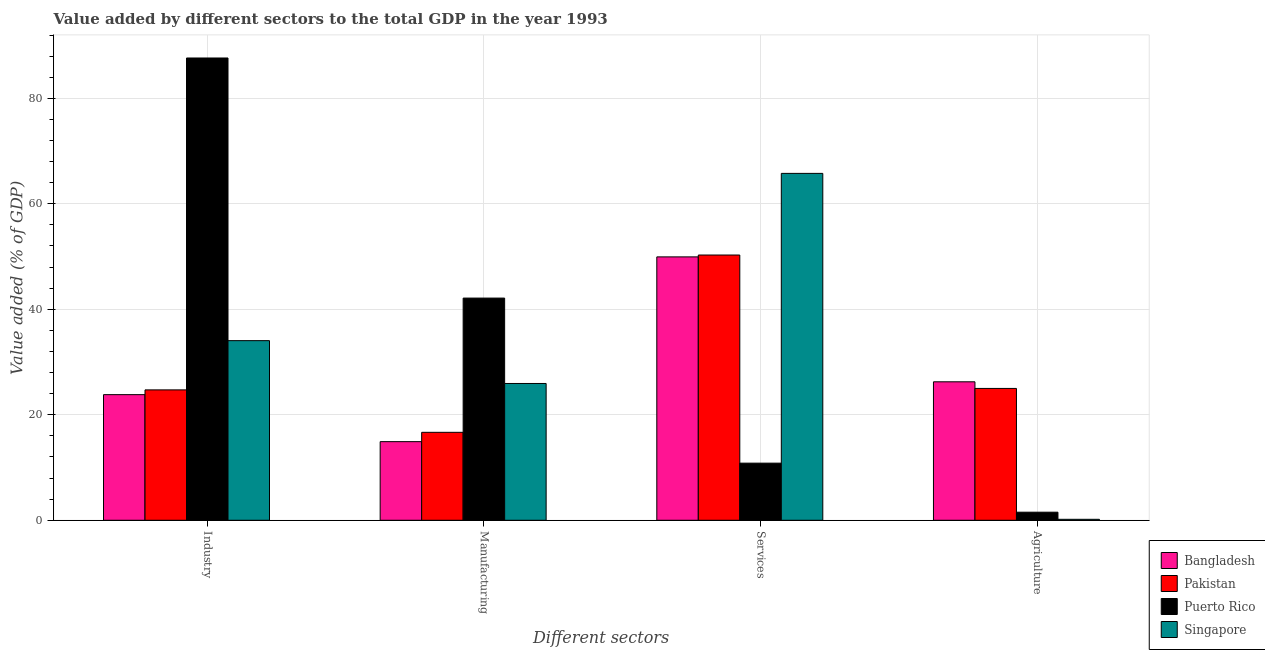Are the number of bars on each tick of the X-axis equal?
Provide a succinct answer. Yes. How many bars are there on the 4th tick from the right?
Give a very brief answer. 4. What is the label of the 3rd group of bars from the left?
Your answer should be very brief. Services. What is the value added by manufacturing sector in Bangladesh?
Give a very brief answer. 14.91. Across all countries, what is the maximum value added by manufacturing sector?
Give a very brief answer. 42.12. Across all countries, what is the minimum value added by services sector?
Your response must be concise. 10.83. In which country was the value added by services sector maximum?
Offer a terse response. Singapore. In which country was the value added by services sector minimum?
Provide a short and direct response. Puerto Rico. What is the total value added by agricultural sector in the graph?
Make the answer very short. 52.96. What is the difference between the value added by services sector in Puerto Rico and that in Singapore?
Give a very brief answer. -54.94. What is the difference between the value added by manufacturing sector in Pakistan and the value added by industrial sector in Puerto Rico?
Your answer should be compact. -70.97. What is the average value added by manufacturing sector per country?
Provide a succinct answer. 24.91. What is the difference between the value added by manufacturing sector and value added by services sector in Singapore?
Your response must be concise. -39.83. What is the ratio of the value added by services sector in Bangladesh to that in Puerto Rico?
Provide a short and direct response. 4.61. Is the value added by agricultural sector in Singapore less than that in Puerto Rico?
Your answer should be compact. Yes. What is the difference between the highest and the second highest value added by manufacturing sector?
Make the answer very short. 16.19. What is the difference between the highest and the lowest value added by industrial sector?
Offer a terse response. 63.83. Is it the case that in every country, the sum of the value added by services sector and value added by agricultural sector is greater than the sum of value added by manufacturing sector and value added by industrial sector?
Offer a terse response. No. Is it the case that in every country, the sum of the value added by industrial sector and value added by manufacturing sector is greater than the value added by services sector?
Provide a succinct answer. No. How many countries are there in the graph?
Offer a very short reply. 4. Where does the legend appear in the graph?
Make the answer very short. Bottom right. How many legend labels are there?
Make the answer very short. 4. What is the title of the graph?
Ensure brevity in your answer.  Value added by different sectors to the total GDP in the year 1993. What is the label or title of the X-axis?
Provide a short and direct response. Different sectors. What is the label or title of the Y-axis?
Ensure brevity in your answer.  Value added (% of GDP). What is the Value added (% of GDP) of Bangladesh in Industry?
Your response must be concise. 23.82. What is the Value added (% of GDP) in Pakistan in Industry?
Keep it short and to the point. 24.72. What is the Value added (% of GDP) of Puerto Rico in Industry?
Offer a terse response. 87.64. What is the Value added (% of GDP) in Singapore in Industry?
Provide a succinct answer. 34.05. What is the Value added (% of GDP) of Bangladesh in Manufacturing?
Keep it short and to the point. 14.91. What is the Value added (% of GDP) in Pakistan in Manufacturing?
Ensure brevity in your answer.  16.67. What is the Value added (% of GDP) of Puerto Rico in Manufacturing?
Ensure brevity in your answer.  42.12. What is the Value added (% of GDP) in Singapore in Manufacturing?
Offer a terse response. 25.93. What is the Value added (% of GDP) in Bangladesh in Services?
Make the answer very short. 49.93. What is the Value added (% of GDP) of Pakistan in Services?
Provide a succinct answer. 50.29. What is the Value added (% of GDP) in Puerto Rico in Services?
Provide a succinct answer. 10.83. What is the Value added (% of GDP) of Singapore in Services?
Provide a short and direct response. 65.76. What is the Value added (% of GDP) in Bangladesh in Agriculture?
Provide a short and direct response. 26.25. What is the Value added (% of GDP) in Pakistan in Agriculture?
Your response must be concise. 24.99. What is the Value added (% of GDP) of Puerto Rico in Agriculture?
Your answer should be very brief. 1.53. What is the Value added (% of GDP) of Singapore in Agriculture?
Provide a short and direct response. 0.18. Across all Different sectors, what is the maximum Value added (% of GDP) in Bangladesh?
Your response must be concise. 49.93. Across all Different sectors, what is the maximum Value added (% of GDP) in Pakistan?
Provide a short and direct response. 50.29. Across all Different sectors, what is the maximum Value added (% of GDP) in Puerto Rico?
Ensure brevity in your answer.  87.64. Across all Different sectors, what is the maximum Value added (% of GDP) in Singapore?
Give a very brief answer. 65.76. Across all Different sectors, what is the minimum Value added (% of GDP) of Bangladesh?
Provide a succinct answer. 14.91. Across all Different sectors, what is the minimum Value added (% of GDP) in Pakistan?
Keep it short and to the point. 16.67. Across all Different sectors, what is the minimum Value added (% of GDP) in Puerto Rico?
Your response must be concise. 1.53. Across all Different sectors, what is the minimum Value added (% of GDP) in Singapore?
Provide a succinct answer. 0.18. What is the total Value added (% of GDP) of Bangladesh in the graph?
Your answer should be very brief. 114.91. What is the total Value added (% of GDP) of Pakistan in the graph?
Keep it short and to the point. 116.67. What is the total Value added (% of GDP) of Puerto Rico in the graph?
Give a very brief answer. 142.12. What is the total Value added (% of GDP) in Singapore in the graph?
Keep it short and to the point. 125.93. What is the difference between the Value added (% of GDP) in Bangladesh in Industry and that in Manufacturing?
Provide a succinct answer. 8.91. What is the difference between the Value added (% of GDP) in Pakistan in Industry and that in Manufacturing?
Your answer should be compact. 8.04. What is the difference between the Value added (% of GDP) of Puerto Rico in Industry and that in Manufacturing?
Give a very brief answer. 45.52. What is the difference between the Value added (% of GDP) of Singapore in Industry and that in Manufacturing?
Offer a terse response. 8.12. What is the difference between the Value added (% of GDP) of Bangladesh in Industry and that in Services?
Your response must be concise. -26.12. What is the difference between the Value added (% of GDP) of Pakistan in Industry and that in Services?
Ensure brevity in your answer.  -25.57. What is the difference between the Value added (% of GDP) in Puerto Rico in Industry and that in Services?
Your answer should be very brief. 76.81. What is the difference between the Value added (% of GDP) of Singapore in Industry and that in Services?
Your response must be concise. -31.71. What is the difference between the Value added (% of GDP) of Bangladesh in Industry and that in Agriculture?
Your answer should be very brief. -2.44. What is the difference between the Value added (% of GDP) of Pakistan in Industry and that in Agriculture?
Ensure brevity in your answer.  -0.28. What is the difference between the Value added (% of GDP) in Puerto Rico in Industry and that in Agriculture?
Offer a very short reply. 86.11. What is the difference between the Value added (% of GDP) in Singapore in Industry and that in Agriculture?
Keep it short and to the point. 33.87. What is the difference between the Value added (% of GDP) in Bangladesh in Manufacturing and that in Services?
Give a very brief answer. -35.03. What is the difference between the Value added (% of GDP) in Pakistan in Manufacturing and that in Services?
Keep it short and to the point. -33.61. What is the difference between the Value added (% of GDP) of Puerto Rico in Manufacturing and that in Services?
Provide a short and direct response. 31.3. What is the difference between the Value added (% of GDP) in Singapore in Manufacturing and that in Services?
Your answer should be compact. -39.83. What is the difference between the Value added (% of GDP) in Bangladesh in Manufacturing and that in Agriculture?
Keep it short and to the point. -11.35. What is the difference between the Value added (% of GDP) in Pakistan in Manufacturing and that in Agriculture?
Your answer should be very brief. -8.32. What is the difference between the Value added (% of GDP) in Puerto Rico in Manufacturing and that in Agriculture?
Offer a very short reply. 40.59. What is the difference between the Value added (% of GDP) of Singapore in Manufacturing and that in Agriculture?
Make the answer very short. 25.75. What is the difference between the Value added (% of GDP) of Bangladesh in Services and that in Agriculture?
Make the answer very short. 23.68. What is the difference between the Value added (% of GDP) in Pakistan in Services and that in Agriculture?
Give a very brief answer. 25.29. What is the difference between the Value added (% of GDP) of Puerto Rico in Services and that in Agriculture?
Provide a short and direct response. 9.3. What is the difference between the Value added (% of GDP) of Singapore in Services and that in Agriculture?
Ensure brevity in your answer.  65.58. What is the difference between the Value added (% of GDP) in Bangladesh in Industry and the Value added (% of GDP) in Pakistan in Manufacturing?
Ensure brevity in your answer.  7.14. What is the difference between the Value added (% of GDP) of Bangladesh in Industry and the Value added (% of GDP) of Puerto Rico in Manufacturing?
Your answer should be compact. -18.31. What is the difference between the Value added (% of GDP) in Bangladesh in Industry and the Value added (% of GDP) in Singapore in Manufacturing?
Keep it short and to the point. -2.12. What is the difference between the Value added (% of GDP) of Pakistan in Industry and the Value added (% of GDP) of Puerto Rico in Manufacturing?
Give a very brief answer. -17.41. What is the difference between the Value added (% of GDP) of Pakistan in Industry and the Value added (% of GDP) of Singapore in Manufacturing?
Provide a short and direct response. -1.22. What is the difference between the Value added (% of GDP) in Puerto Rico in Industry and the Value added (% of GDP) in Singapore in Manufacturing?
Give a very brief answer. 61.71. What is the difference between the Value added (% of GDP) of Bangladesh in Industry and the Value added (% of GDP) of Pakistan in Services?
Provide a succinct answer. -26.47. What is the difference between the Value added (% of GDP) in Bangladesh in Industry and the Value added (% of GDP) in Puerto Rico in Services?
Keep it short and to the point. 12.99. What is the difference between the Value added (% of GDP) of Bangladesh in Industry and the Value added (% of GDP) of Singapore in Services?
Your answer should be compact. -41.95. What is the difference between the Value added (% of GDP) in Pakistan in Industry and the Value added (% of GDP) in Puerto Rico in Services?
Your response must be concise. 13.89. What is the difference between the Value added (% of GDP) of Pakistan in Industry and the Value added (% of GDP) of Singapore in Services?
Provide a short and direct response. -41.05. What is the difference between the Value added (% of GDP) in Puerto Rico in Industry and the Value added (% of GDP) in Singapore in Services?
Provide a succinct answer. 21.88. What is the difference between the Value added (% of GDP) in Bangladesh in Industry and the Value added (% of GDP) in Pakistan in Agriculture?
Offer a terse response. -1.18. What is the difference between the Value added (% of GDP) in Bangladesh in Industry and the Value added (% of GDP) in Puerto Rico in Agriculture?
Provide a succinct answer. 22.29. What is the difference between the Value added (% of GDP) of Bangladesh in Industry and the Value added (% of GDP) of Singapore in Agriculture?
Make the answer very short. 23.63. What is the difference between the Value added (% of GDP) of Pakistan in Industry and the Value added (% of GDP) of Puerto Rico in Agriculture?
Ensure brevity in your answer.  23.19. What is the difference between the Value added (% of GDP) of Pakistan in Industry and the Value added (% of GDP) of Singapore in Agriculture?
Your response must be concise. 24.53. What is the difference between the Value added (% of GDP) of Puerto Rico in Industry and the Value added (% of GDP) of Singapore in Agriculture?
Give a very brief answer. 87.46. What is the difference between the Value added (% of GDP) in Bangladesh in Manufacturing and the Value added (% of GDP) in Pakistan in Services?
Ensure brevity in your answer.  -35.38. What is the difference between the Value added (% of GDP) in Bangladesh in Manufacturing and the Value added (% of GDP) in Puerto Rico in Services?
Your response must be concise. 4.08. What is the difference between the Value added (% of GDP) of Bangladesh in Manufacturing and the Value added (% of GDP) of Singapore in Services?
Your response must be concise. -50.86. What is the difference between the Value added (% of GDP) in Pakistan in Manufacturing and the Value added (% of GDP) in Puerto Rico in Services?
Offer a terse response. 5.85. What is the difference between the Value added (% of GDP) of Pakistan in Manufacturing and the Value added (% of GDP) of Singapore in Services?
Give a very brief answer. -49.09. What is the difference between the Value added (% of GDP) in Puerto Rico in Manufacturing and the Value added (% of GDP) in Singapore in Services?
Ensure brevity in your answer.  -23.64. What is the difference between the Value added (% of GDP) of Bangladesh in Manufacturing and the Value added (% of GDP) of Pakistan in Agriculture?
Offer a terse response. -10.09. What is the difference between the Value added (% of GDP) of Bangladesh in Manufacturing and the Value added (% of GDP) of Puerto Rico in Agriculture?
Make the answer very short. 13.38. What is the difference between the Value added (% of GDP) in Bangladesh in Manufacturing and the Value added (% of GDP) in Singapore in Agriculture?
Keep it short and to the point. 14.72. What is the difference between the Value added (% of GDP) of Pakistan in Manufacturing and the Value added (% of GDP) of Puerto Rico in Agriculture?
Your response must be concise. 15.14. What is the difference between the Value added (% of GDP) of Pakistan in Manufacturing and the Value added (% of GDP) of Singapore in Agriculture?
Provide a short and direct response. 16.49. What is the difference between the Value added (% of GDP) of Puerto Rico in Manufacturing and the Value added (% of GDP) of Singapore in Agriculture?
Offer a terse response. 41.94. What is the difference between the Value added (% of GDP) of Bangladesh in Services and the Value added (% of GDP) of Pakistan in Agriculture?
Ensure brevity in your answer.  24.94. What is the difference between the Value added (% of GDP) in Bangladesh in Services and the Value added (% of GDP) in Puerto Rico in Agriculture?
Your answer should be compact. 48.4. What is the difference between the Value added (% of GDP) of Bangladesh in Services and the Value added (% of GDP) of Singapore in Agriculture?
Ensure brevity in your answer.  49.75. What is the difference between the Value added (% of GDP) in Pakistan in Services and the Value added (% of GDP) in Puerto Rico in Agriculture?
Ensure brevity in your answer.  48.76. What is the difference between the Value added (% of GDP) in Pakistan in Services and the Value added (% of GDP) in Singapore in Agriculture?
Offer a very short reply. 50.11. What is the difference between the Value added (% of GDP) in Puerto Rico in Services and the Value added (% of GDP) in Singapore in Agriculture?
Provide a short and direct response. 10.64. What is the average Value added (% of GDP) of Bangladesh per Different sectors?
Make the answer very short. 28.73. What is the average Value added (% of GDP) in Pakistan per Different sectors?
Your answer should be very brief. 29.17. What is the average Value added (% of GDP) in Puerto Rico per Different sectors?
Offer a terse response. 35.53. What is the average Value added (% of GDP) in Singapore per Different sectors?
Make the answer very short. 31.48. What is the difference between the Value added (% of GDP) in Bangladesh and Value added (% of GDP) in Pakistan in Industry?
Give a very brief answer. -0.9. What is the difference between the Value added (% of GDP) of Bangladesh and Value added (% of GDP) of Puerto Rico in Industry?
Make the answer very short. -63.83. What is the difference between the Value added (% of GDP) in Bangladesh and Value added (% of GDP) in Singapore in Industry?
Provide a short and direct response. -10.24. What is the difference between the Value added (% of GDP) of Pakistan and Value added (% of GDP) of Puerto Rico in Industry?
Your answer should be compact. -62.92. What is the difference between the Value added (% of GDP) of Pakistan and Value added (% of GDP) of Singapore in Industry?
Your answer should be compact. -9.34. What is the difference between the Value added (% of GDP) of Puerto Rico and Value added (% of GDP) of Singapore in Industry?
Your response must be concise. 53.59. What is the difference between the Value added (% of GDP) of Bangladesh and Value added (% of GDP) of Pakistan in Manufacturing?
Give a very brief answer. -1.77. What is the difference between the Value added (% of GDP) in Bangladesh and Value added (% of GDP) in Puerto Rico in Manufacturing?
Give a very brief answer. -27.22. What is the difference between the Value added (% of GDP) of Bangladesh and Value added (% of GDP) of Singapore in Manufacturing?
Provide a short and direct response. -11.03. What is the difference between the Value added (% of GDP) of Pakistan and Value added (% of GDP) of Puerto Rico in Manufacturing?
Keep it short and to the point. -25.45. What is the difference between the Value added (% of GDP) in Pakistan and Value added (% of GDP) in Singapore in Manufacturing?
Keep it short and to the point. -9.26. What is the difference between the Value added (% of GDP) of Puerto Rico and Value added (% of GDP) of Singapore in Manufacturing?
Offer a very short reply. 16.19. What is the difference between the Value added (% of GDP) in Bangladesh and Value added (% of GDP) in Pakistan in Services?
Provide a short and direct response. -0.36. What is the difference between the Value added (% of GDP) in Bangladesh and Value added (% of GDP) in Puerto Rico in Services?
Offer a terse response. 39.11. What is the difference between the Value added (% of GDP) of Bangladesh and Value added (% of GDP) of Singapore in Services?
Your answer should be compact. -15.83. What is the difference between the Value added (% of GDP) of Pakistan and Value added (% of GDP) of Puerto Rico in Services?
Your answer should be compact. 39.46. What is the difference between the Value added (% of GDP) in Pakistan and Value added (% of GDP) in Singapore in Services?
Provide a short and direct response. -15.48. What is the difference between the Value added (% of GDP) in Puerto Rico and Value added (% of GDP) in Singapore in Services?
Provide a short and direct response. -54.94. What is the difference between the Value added (% of GDP) in Bangladesh and Value added (% of GDP) in Pakistan in Agriculture?
Your response must be concise. 1.26. What is the difference between the Value added (% of GDP) in Bangladesh and Value added (% of GDP) in Puerto Rico in Agriculture?
Offer a terse response. 24.72. What is the difference between the Value added (% of GDP) in Bangladesh and Value added (% of GDP) in Singapore in Agriculture?
Provide a short and direct response. 26.07. What is the difference between the Value added (% of GDP) in Pakistan and Value added (% of GDP) in Puerto Rico in Agriculture?
Provide a succinct answer. 23.46. What is the difference between the Value added (% of GDP) in Pakistan and Value added (% of GDP) in Singapore in Agriculture?
Your answer should be very brief. 24.81. What is the difference between the Value added (% of GDP) of Puerto Rico and Value added (% of GDP) of Singapore in Agriculture?
Your answer should be compact. 1.35. What is the ratio of the Value added (% of GDP) in Bangladesh in Industry to that in Manufacturing?
Give a very brief answer. 1.6. What is the ratio of the Value added (% of GDP) in Pakistan in Industry to that in Manufacturing?
Provide a succinct answer. 1.48. What is the ratio of the Value added (% of GDP) of Puerto Rico in Industry to that in Manufacturing?
Your response must be concise. 2.08. What is the ratio of the Value added (% of GDP) of Singapore in Industry to that in Manufacturing?
Your answer should be very brief. 1.31. What is the ratio of the Value added (% of GDP) in Bangladesh in Industry to that in Services?
Your answer should be very brief. 0.48. What is the ratio of the Value added (% of GDP) of Pakistan in Industry to that in Services?
Give a very brief answer. 0.49. What is the ratio of the Value added (% of GDP) of Puerto Rico in Industry to that in Services?
Provide a succinct answer. 8.09. What is the ratio of the Value added (% of GDP) in Singapore in Industry to that in Services?
Offer a very short reply. 0.52. What is the ratio of the Value added (% of GDP) of Bangladesh in Industry to that in Agriculture?
Make the answer very short. 0.91. What is the ratio of the Value added (% of GDP) of Pakistan in Industry to that in Agriculture?
Provide a succinct answer. 0.99. What is the ratio of the Value added (% of GDP) of Puerto Rico in Industry to that in Agriculture?
Keep it short and to the point. 57.27. What is the ratio of the Value added (% of GDP) in Singapore in Industry to that in Agriculture?
Make the answer very short. 186.02. What is the ratio of the Value added (% of GDP) in Bangladesh in Manufacturing to that in Services?
Keep it short and to the point. 0.3. What is the ratio of the Value added (% of GDP) of Pakistan in Manufacturing to that in Services?
Keep it short and to the point. 0.33. What is the ratio of the Value added (% of GDP) of Puerto Rico in Manufacturing to that in Services?
Give a very brief answer. 3.89. What is the ratio of the Value added (% of GDP) of Singapore in Manufacturing to that in Services?
Your answer should be compact. 0.39. What is the ratio of the Value added (% of GDP) of Bangladesh in Manufacturing to that in Agriculture?
Ensure brevity in your answer.  0.57. What is the ratio of the Value added (% of GDP) of Pakistan in Manufacturing to that in Agriculture?
Give a very brief answer. 0.67. What is the ratio of the Value added (% of GDP) in Puerto Rico in Manufacturing to that in Agriculture?
Keep it short and to the point. 27.53. What is the ratio of the Value added (% of GDP) in Singapore in Manufacturing to that in Agriculture?
Your answer should be compact. 141.67. What is the ratio of the Value added (% of GDP) of Bangladesh in Services to that in Agriculture?
Offer a very short reply. 1.9. What is the ratio of the Value added (% of GDP) in Pakistan in Services to that in Agriculture?
Keep it short and to the point. 2.01. What is the ratio of the Value added (% of GDP) of Puerto Rico in Services to that in Agriculture?
Ensure brevity in your answer.  7.08. What is the ratio of the Value added (% of GDP) of Singapore in Services to that in Agriculture?
Your response must be concise. 359.23. What is the difference between the highest and the second highest Value added (% of GDP) of Bangladesh?
Provide a succinct answer. 23.68. What is the difference between the highest and the second highest Value added (% of GDP) in Pakistan?
Keep it short and to the point. 25.29. What is the difference between the highest and the second highest Value added (% of GDP) in Puerto Rico?
Provide a succinct answer. 45.52. What is the difference between the highest and the second highest Value added (% of GDP) of Singapore?
Your answer should be very brief. 31.71. What is the difference between the highest and the lowest Value added (% of GDP) of Bangladesh?
Your answer should be very brief. 35.03. What is the difference between the highest and the lowest Value added (% of GDP) of Pakistan?
Offer a terse response. 33.61. What is the difference between the highest and the lowest Value added (% of GDP) of Puerto Rico?
Offer a terse response. 86.11. What is the difference between the highest and the lowest Value added (% of GDP) of Singapore?
Offer a terse response. 65.58. 